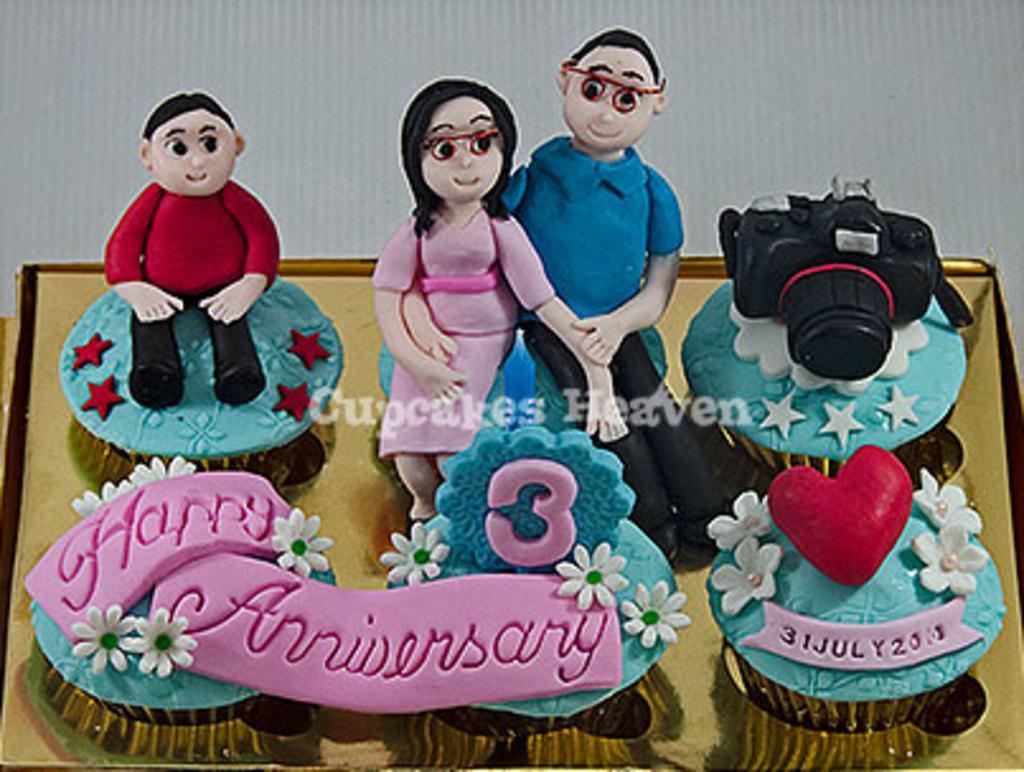Describe this image in one or two sentences. In this image there is a cake with a few artificial flowers, a camera and a few toys. In the background it seems to be a cardboard box. 